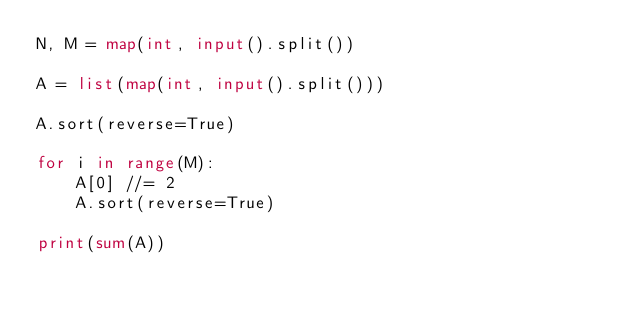Convert code to text. <code><loc_0><loc_0><loc_500><loc_500><_Python_>N, M = map(int, input().split())

A = list(map(int, input().split()))

A.sort(reverse=True)

for i in range(M):
    A[0] //= 2
    A.sort(reverse=True)

print(sum(A))</code> 